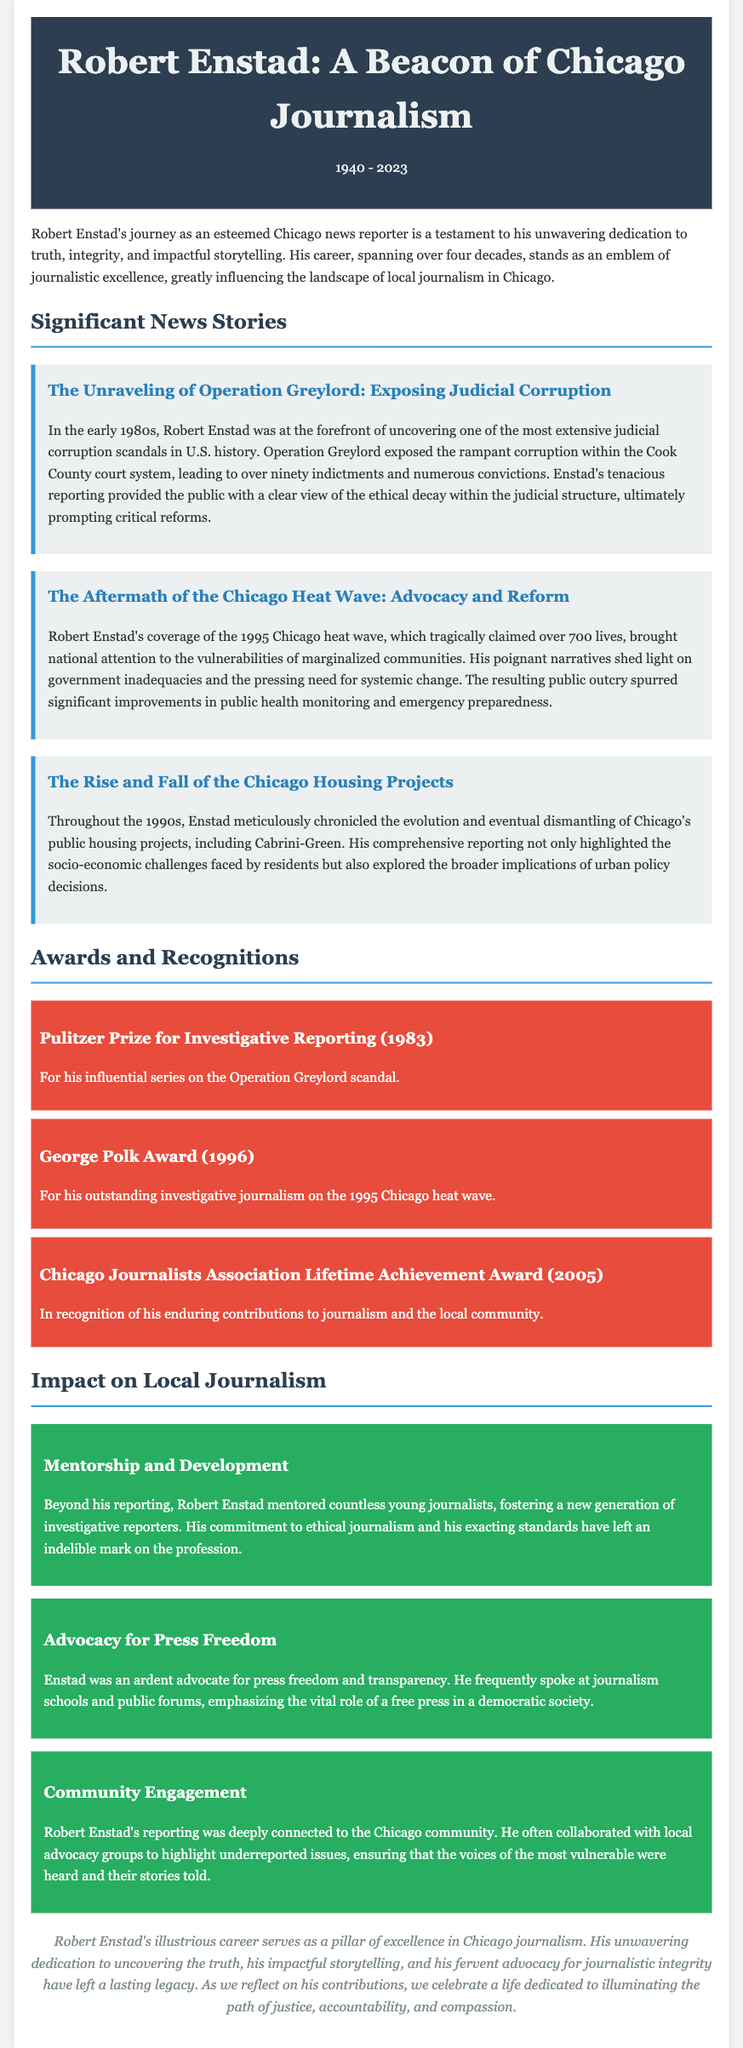what year was Robert Enstad born? The document states Robert Enstad was born in 1940.
Answer: 1940 how many years did Robert Enstad's career span? The text indicates that his career spanned over four decades.
Answer: over four decades what significant scandal did Enstad cover in the 1980s? The document refers to Operation Greylord, which was a major judicial corruption scandal he reported on.
Answer: Operation Greylord which award did Enstad receive for his work in 1983? The obituary mentions that he received the Pulitzer Prize for Investigative Reporting for his series on the Operation Greylord scandal in 1983.
Answer: Pulitzer Prize for Investigative Reporting how many lives were lost during the Chicago heat wave of 1995? The document mentions that the heat wave tragically claimed over 700 lives.
Answer: over 700 lives what is one area of impact highlighted in the obituary? The article discusses several impacts, including Enstad's mentorship to young journalists.
Answer: Mentorship which award recognizes Enstad's lifetime contributions? According to the document, he received the Chicago Journalists Association Lifetime Achievement Award in 2005.
Answer: Chicago Journalists Association Lifetime Achievement Award who did Enstad often collaborate with to highlight underreported issues? The obituary states he collaborated with local advocacy groups to ensure the voices of the most vulnerable were heard.
Answer: local advocacy groups what was Enstad's stance on press freedom? The document indicates that he was an ardent advocate for press freedom and transparency.
Answer: an ardent advocate for press freedom 